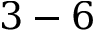<formula> <loc_0><loc_0><loc_500><loc_500>3 - 6</formula> 